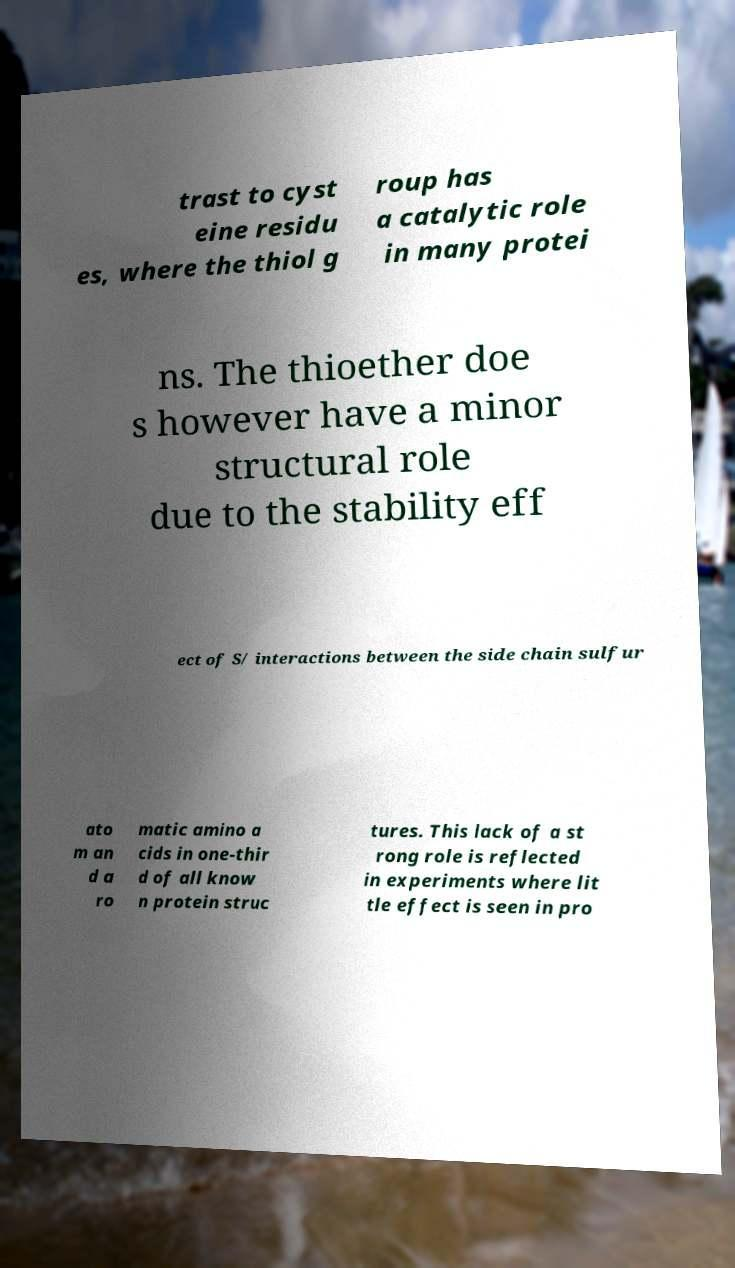There's text embedded in this image that I need extracted. Can you transcribe it verbatim? trast to cyst eine residu es, where the thiol g roup has a catalytic role in many protei ns. The thioether doe s however have a minor structural role due to the stability eff ect of S/ interactions between the side chain sulfur ato m an d a ro matic amino a cids in one-thir d of all know n protein struc tures. This lack of a st rong role is reflected in experiments where lit tle effect is seen in pro 